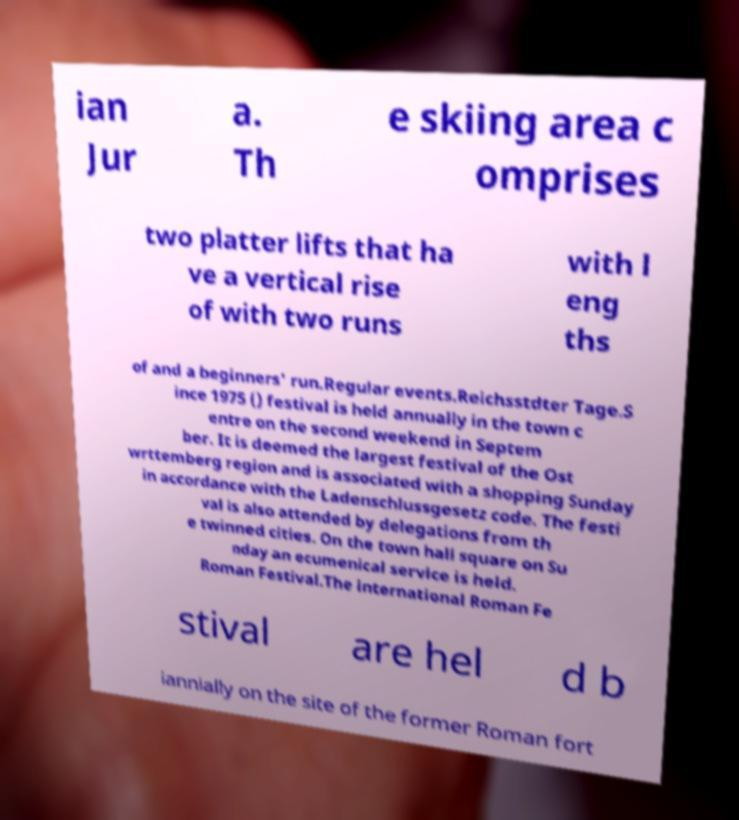Can you read and provide the text displayed in the image?This photo seems to have some interesting text. Can you extract and type it out for me? ian Jur a. Th e skiing area c omprises two platter lifts that ha ve a vertical rise of with two runs with l eng ths of and a beginners' run.Regular events.Reichsstdter Tage.S ince 1975 () festival is held annually in the town c entre on the second weekend in Septem ber. It is deemed the largest festival of the Ost wrttemberg region and is associated with a shopping Sunday in accordance with the Ladenschlussgesetz code. The festi val is also attended by delegations from th e twinned cities. On the town hall square on Su nday an ecumenical service is held. Roman Festival.The international Roman Fe stival are hel d b iannially on the site of the former Roman fort 